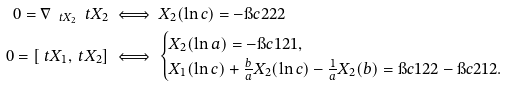<formula> <loc_0><loc_0><loc_500><loc_500>0 = \nabla _ { \ t X _ { 2 } } \ t X _ { 2 } & \iff X _ { 2 } ( \ln c ) = - \i c 2 2 2 \\ 0 = [ \ t X _ { 1 } , \ t X _ { 2 } ] & \iff \begin{cases} X _ { 2 } ( \ln a ) = - \i c 1 2 1 , \\ X _ { 1 } ( \ln c ) + \frac { b } { a } X _ { 2 } ( \ln c ) - \frac { 1 } { a } X _ { 2 } ( b ) = \i c 1 2 2 - \i c 2 1 2 . \end{cases}</formula> 